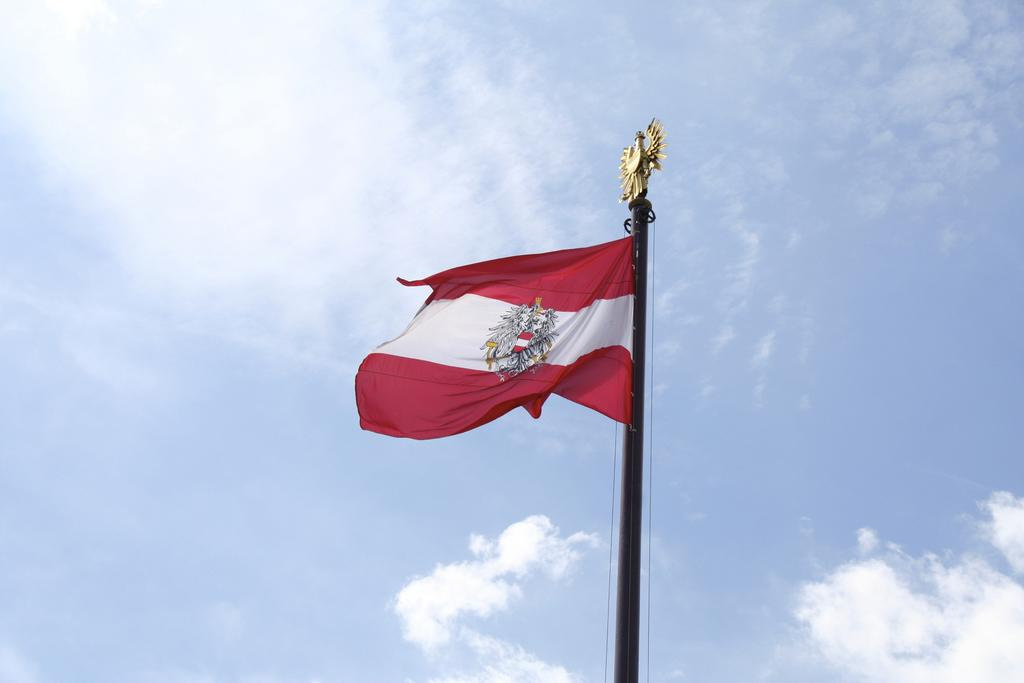What is on the pole in the image? There is a flag on a pole in the image. What can be seen in the background of the image? The sky is visible in the background of the image. What type of shoe is hanging from the flagpole in the image? There is no shoe present in the image; it only features a flag on a pole. 